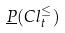<formula> <loc_0><loc_0><loc_500><loc_500>\underline { P } ( C l _ { t } ^ { \leq } )</formula> 